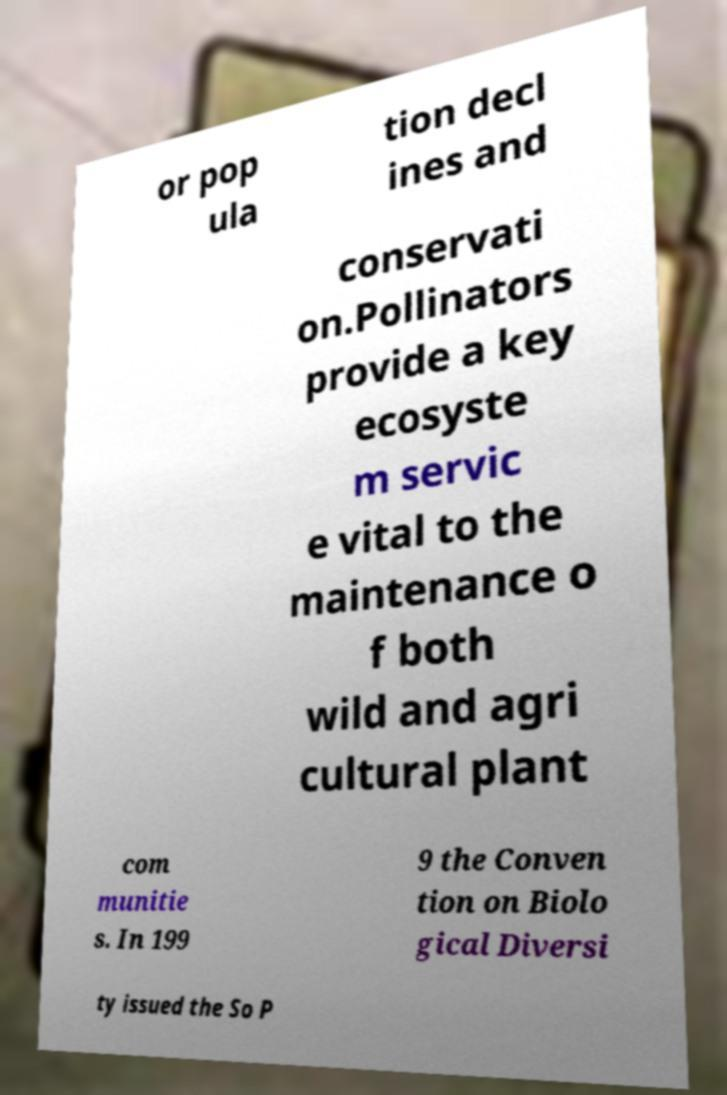Please identify and transcribe the text found in this image. or pop ula tion decl ines and conservati on.Pollinators provide a key ecosyste m servic e vital to the maintenance o f both wild and agri cultural plant com munitie s. In 199 9 the Conven tion on Biolo gical Diversi ty issued the So P 